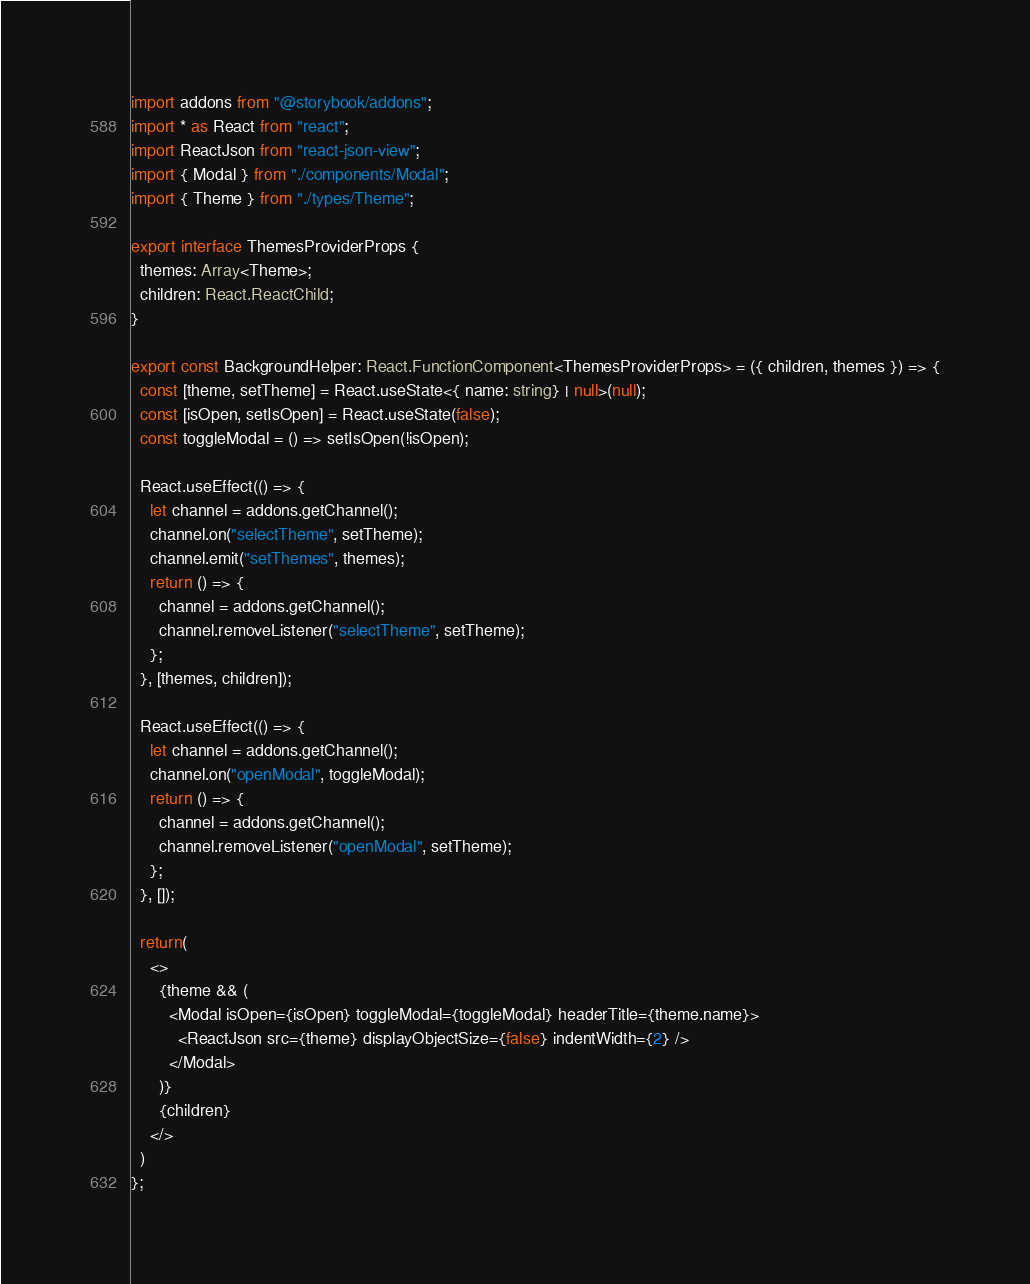Convert code to text. <code><loc_0><loc_0><loc_500><loc_500><_TypeScript_>import addons from "@storybook/addons";
import * as React from "react";
import ReactJson from "react-json-view";
import { Modal } from "./components/Modal";
import { Theme } from "./types/Theme";

export interface ThemesProviderProps {
  themes: Array<Theme>;
  children: React.ReactChild;
}

export const BackgroundHelper: React.FunctionComponent<ThemesProviderProps> = ({ children, themes }) => {
  const [theme, setTheme] = React.useState<{ name: string} | null>(null);
  const [isOpen, setIsOpen] = React.useState(false);
  const toggleModal = () => setIsOpen(!isOpen);

  React.useEffect(() => {
    let channel = addons.getChannel();
    channel.on("selectTheme", setTheme);
    channel.emit("setThemes", themes);
    return () => {
      channel = addons.getChannel();
      channel.removeListener("selectTheme", setTheme);
    };
  }, [themes, children]);

  React.useEffect(() => {
    let channel = addons.getChannel();
    channel.on("openModal", toggleModal);
    return () => {
      channel = addons.getChannel();
      channel.removeListener("openModal", setTheme);
    };
  }, []);

  return(
    <>
      {theme && (
        <Modal isOpen={isOpen} toggleModal={toggleModal} headerTitle={theme.name}>
          <ReactJson src={theme} displayObjectSize={false} indentWidth={2} />
        </Modal>
      )}
      {children}
    </>
  )
};
</code> 